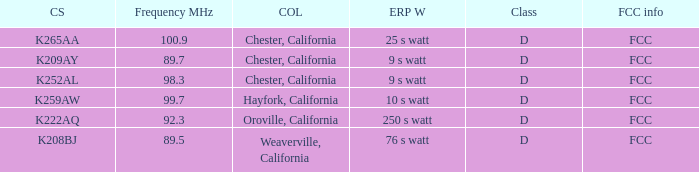Name the call sign with frequency of 89.5 K208BJ. 